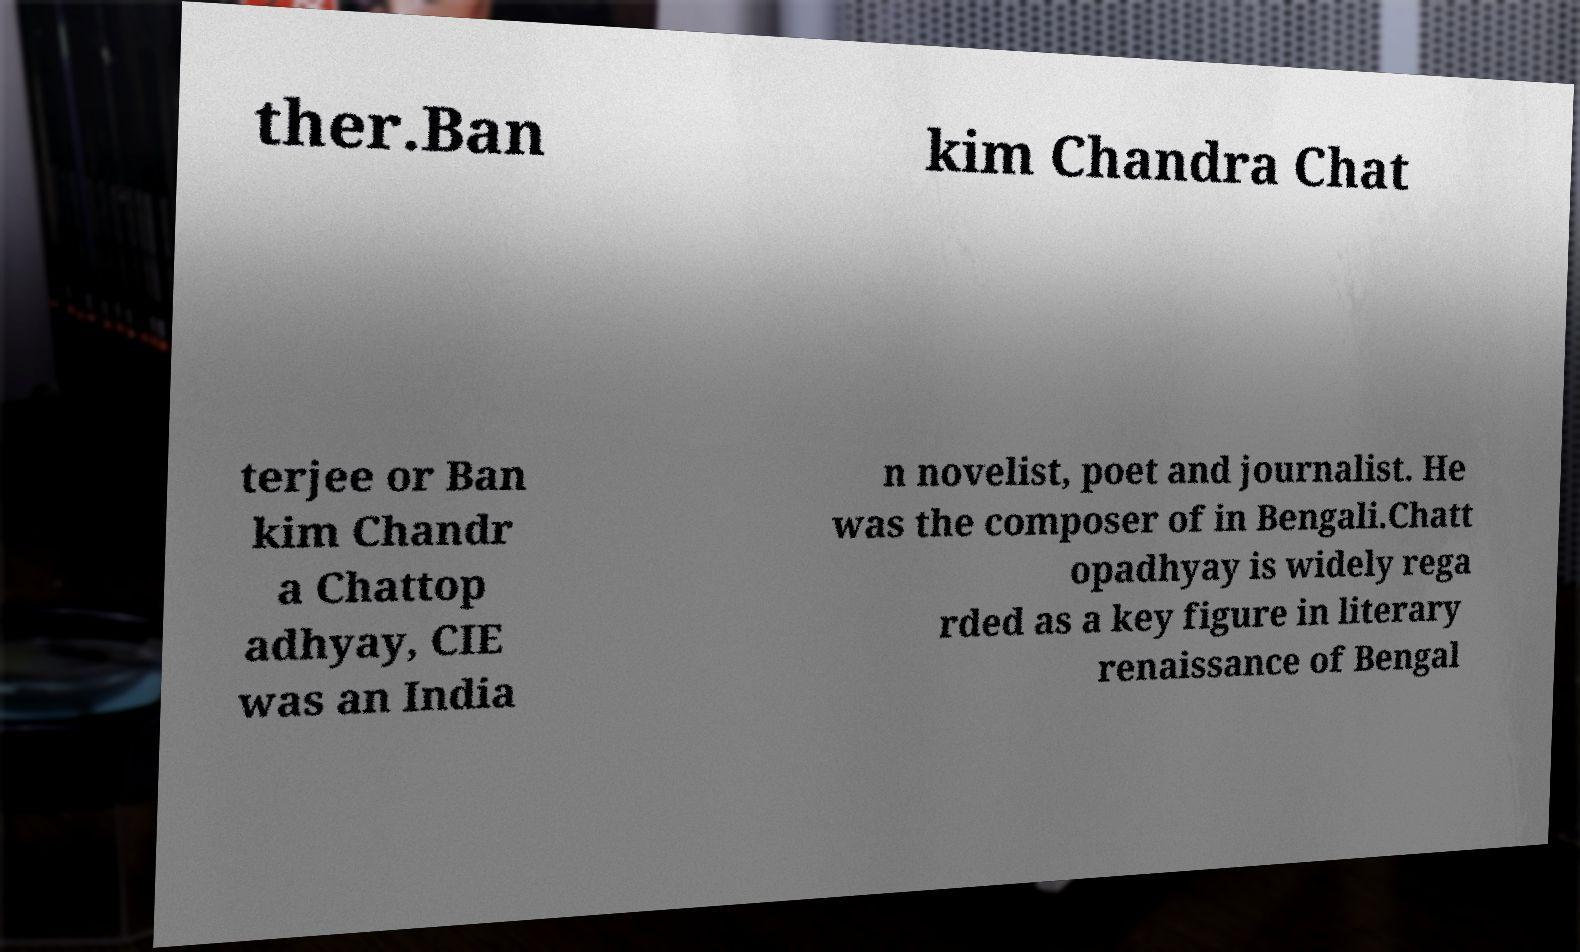Can you accurately transcribe the text from the provided image for me? ther.Ban kim Chandra Chat terjee or Ban kim Chandr a Chattop adhyay, CIE was an India n novelist, poet and journalist. He was the composer of in Bengali.Chatt opadhyay is widely rega rded as a key figure in literary renaissance of Bengal 